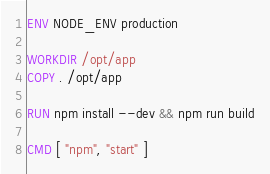<code> <loc_0><loc_0><loc_500><loc_500><_Dockerfile_>
ENV NODE_ENV production

WORKDIR /opt/app
COPY . /opt/app

RUN npm install --dev && npm run build

CMD [ "npm", "start" ]
</code> 